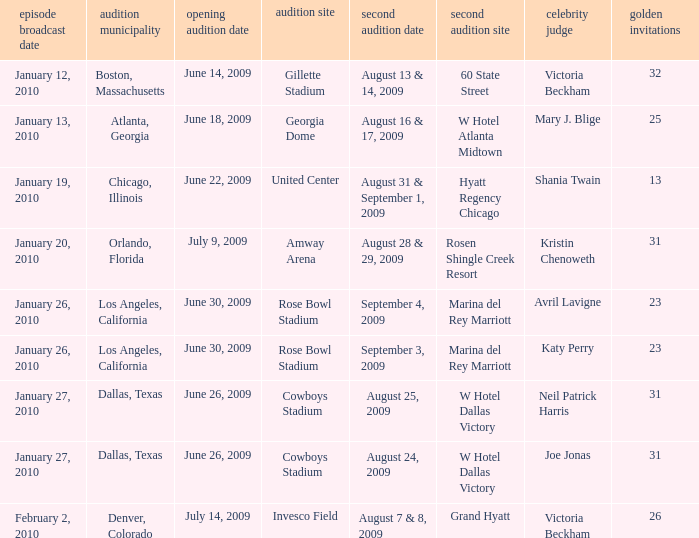Name the total number of golden tickets being rosen shingle creek resort 1.0. 